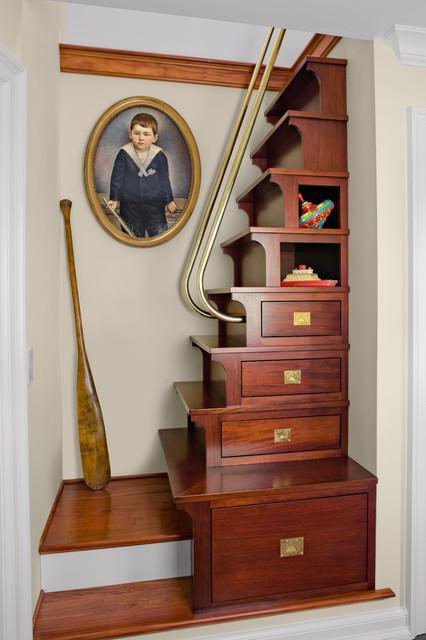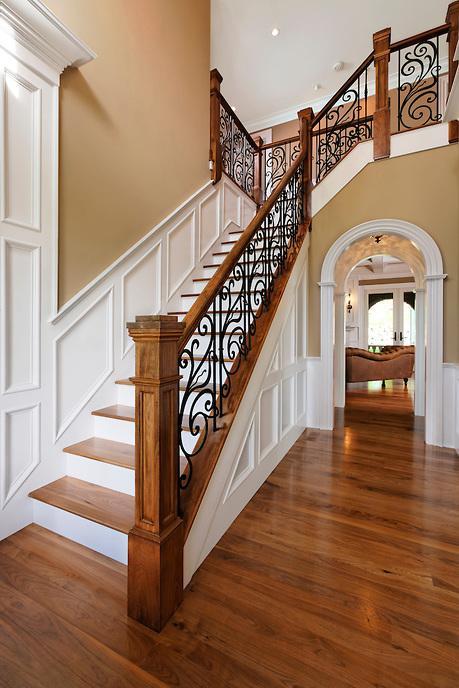The first image is the image on the left, the second image is the image on the right. Given the left and right images, does the statement "IN at least one image there is at least one sofa chair to the side of a staircase on the first floor." hold true? Answer yes or no. No. 